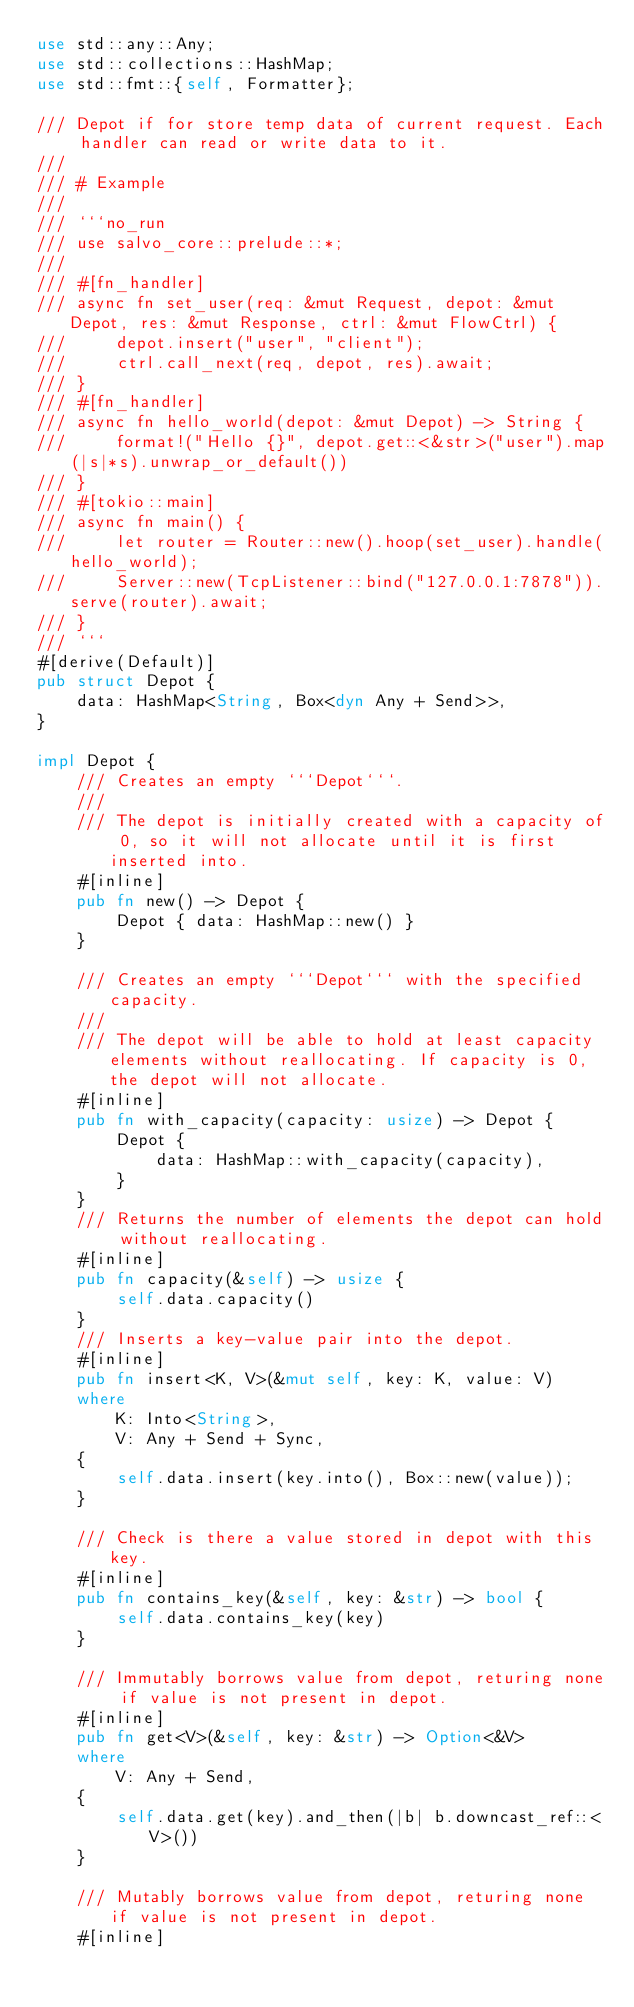<code> <loc_0><loc_0><loc_500><loc_500><_Rust_>use std::any::Any;
use std::collections::HashMap;
use std::fmt::{self, Formatter};

/// Depot if for store temp data of current request. Each handler can read or write data to it.
///
/// # Example
///
/// ```no_run
/// use salvo_core::prelude::*;
///
/// #[fn_handler]
/// async fn set_user(req: &mut Request, depot: &mut Depot, res: &mut Response, ctrl: &mut FlowCtrl) {
///     depot.insert("user", "client");
///     ctrl.call_next(req, depot, res).await;
/// }
/// #[fn_handler]
/// async fn hello_world(depot: &mut Depot) -> String {
///     format!("Hello {}", depot.get::<&str>("user").map(|s|*s).unwrap_or_default())
/// }
/// #[tokio::main]
/// async fn main() {
///     let router = Router::new().hoop(set_user).handle(hello_world);
///     Server::new(TcpListener::bind("127.0.0.1:7878")).serve(router).await;
/// }
/// ```
#[derive(Default)]
pub struct Depot {
    data: HashMap<String, Box<dyn Any + Send>>,
}

impl Depot {
    /// Creates an empty ```Depot```.
    ///
    /// The depot is initially created with a capacity of 0, so it will not allocate until it is first inserted into.
    #[inline]
    pub fn new() -> Depot {
        Depot { data: HashMap::new() }
    }

    /// Creates an empty ```Depot``` with the specified capacity.
    ///
    /// The depot will be able to hold at least capacity elements without reallocating. If capacity is 0, the depot will not allocate.
    #[inline]
    pub fn with_capacity(capacity: usize) -> Depot {
        Depot {
            data: HashMap::with_capacity(capacity),
        }
    }
    /// Returns the number of elements the depot can hold without reallocating.
    #[inline]
    pub fn capacity(&self) -> usize {
        self.data.capacity()
    }
    /// Inserts a key-value pair into the depot.
    #[inline]
    pub fn insert<K, V>(&mut self, key: K, value: V)
    where
        K: Into<String>,
        V: Any + Send + Sync,
    {
        self.data.insert(key.into(), Box::new(value));
    }

    /// Check is there a value stored in depot with this key.
    #[inline]
    pub fn contains_key(&self, key: &str) -> bool {
        self.data.contains_key(key)
    }

    /// Immutably borrows value from depot, returing none if value is not present in depot.
    #[inline]
    pub fn get<V>(&self, key: &str) -> Option<&V>
    where
        V: Any + Send,
    {
        self.data.get(key).and_then(|b| b.downcast_ref::<V>())
    }

    /// Mutably borrows value from depot, returing none if value is not present in depot.
    #[inline]</code> 